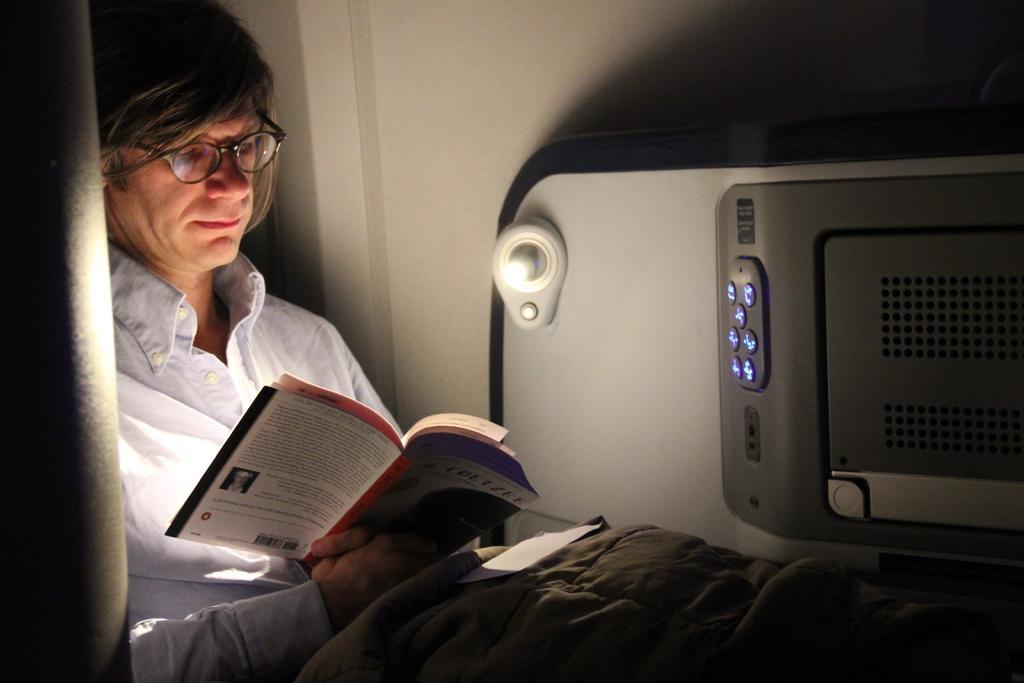Describe this image in one or two sentences. In this picture I can see a person sitting and holding a book, there is a paper on the blanket, and in the background there is a wall and there is an object. 